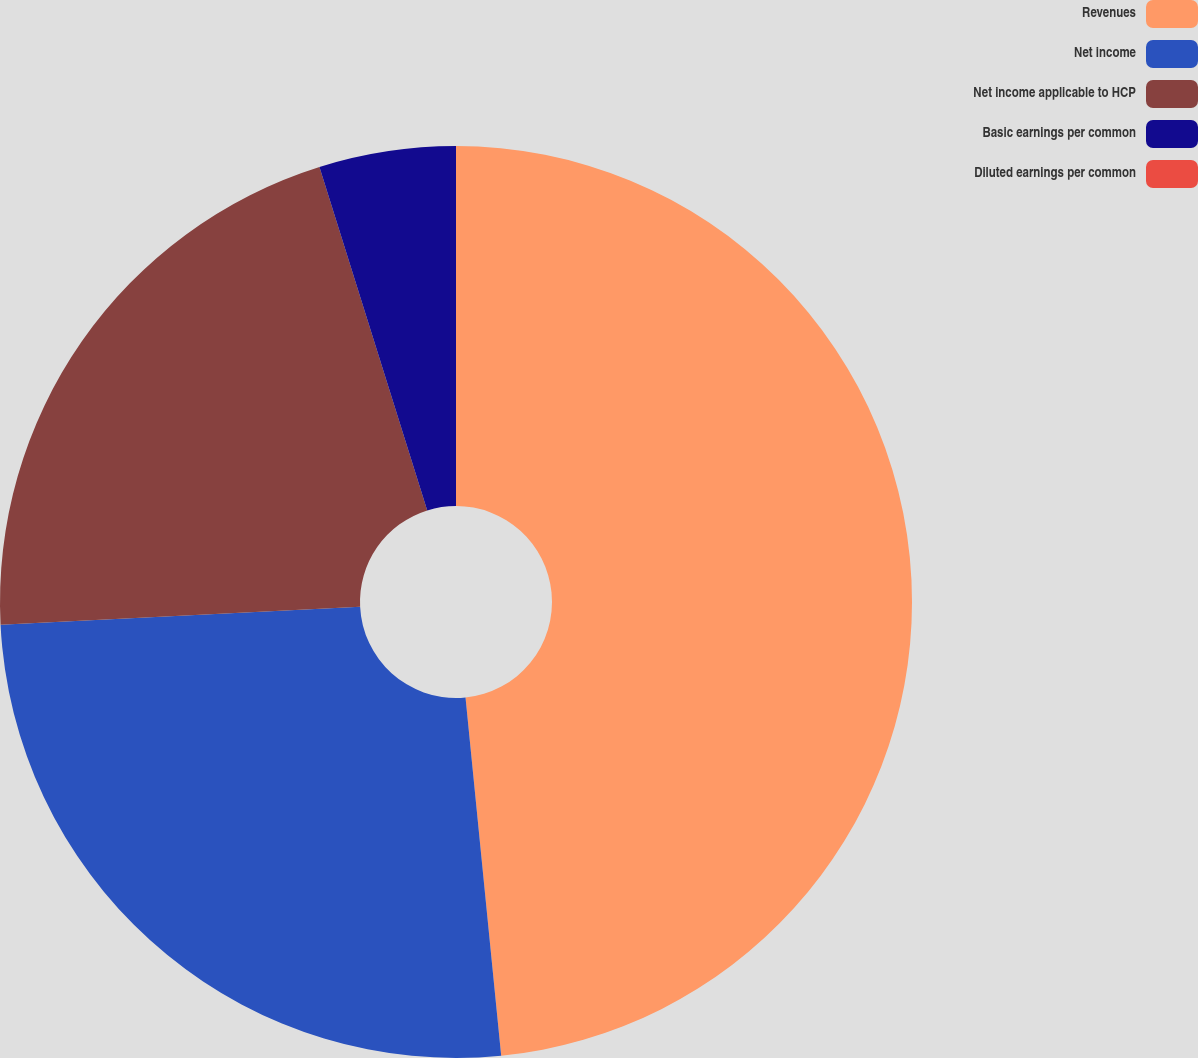Convert chart to OTSL. <chart><loc_0><loc_0><loc_500><loc_500><pie_chart><fcel>Revenues<fcel>Net income<fcel>Net income applicable to HCP<fcel>Basic earnings per common<fcel>Diluted earnings per common<nl><fcel>48.42%<fcel>25.79%<fcel>20.95%<fcel>4.84%<fcel>0.0%<nl></chart> 